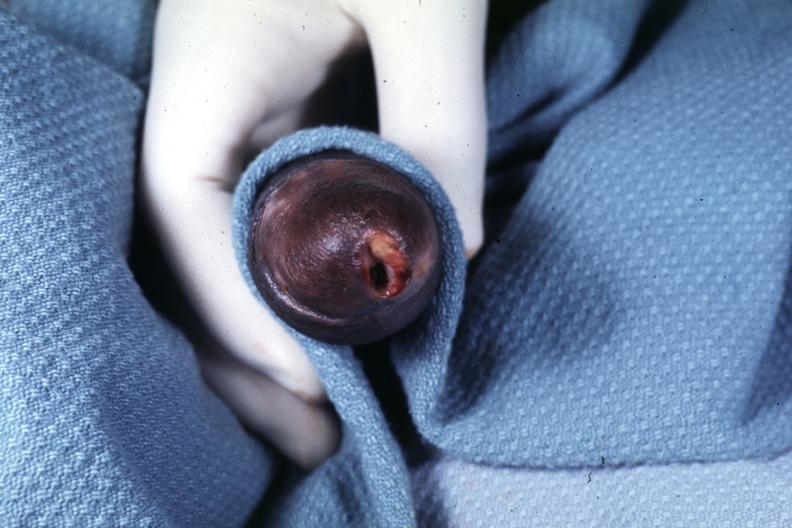s penis present?
Answer the question using a single word or phrase. Yes 